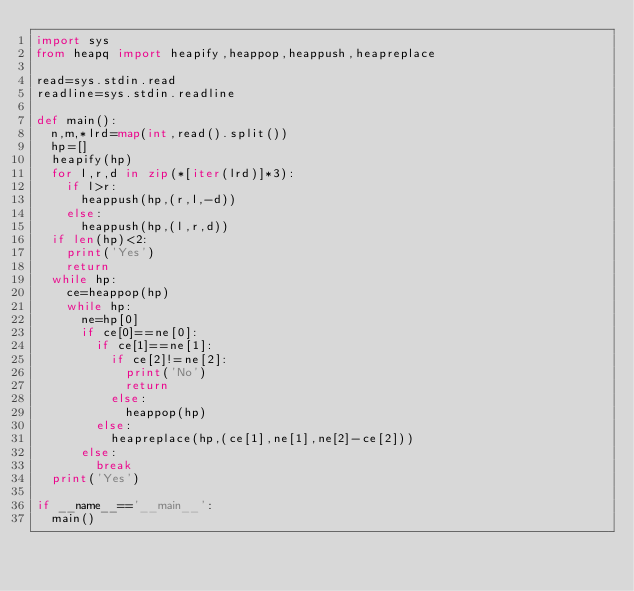Convert code to text. <code><loc_0><loc_0><loc_500><loc_500><_Python_>import sys
from heapq import heapify,heappop,heappush,heapreplace

read=sys.stdin.read
readline=sys.stdin.readline

def main():
  n,m,*lrd=map(int,read().split())
  hp=[]
  heapify(hp)
  for l,r,d in zip(*[iter(lrd)]*3):
    if l>r:
      heappush(hp,(r,l,-d))
    else:
      heappush(hp,(l,r,d))
  if len(hp)<2:
    print('Yes')
    return
  while hp:
    ce=heappop(hp)
    while hp:
      ne=hp[0]
      if ce[0]==ne[0]:
        if ce[1]==ne[1]:
          if ce[2]!=ne[2]:
            print('No')
            return
          else:
            heappop(hp)
        else:
          heapreplace(hp,(ce[1],ne[1],ne[2]-ce[2]))
      else:
        break      
  print('Yes')

if __name__=='__main__':
  main()
      
    
    </code> 